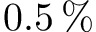<formula> <loc_0><loc_0><loc_500><loc_500>0 . 5 \, \%</formula> 